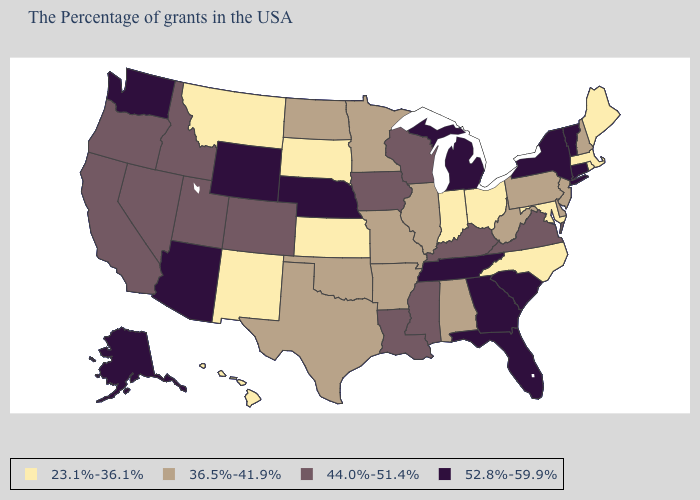Name the states that have a value in the range 23.1%-36.1%?
Write a very short answer. Maine, Massachusetts, Rhode Island, Maryland, North Carolina, Ohio, Indiana, Kansas, South Dakota, New Mexico, Montana, Hawaii. What is the highest value in the South ?
Be succinct. 52.8%-59.9%. What is the value of Oklahoma?
Concise answer only. 36.5%-41.9%. What is the value of Oklahoma?
Write a very short answer. 36.5%-41.9%. Name the states that have a value in the range 52.8%-59.9%?
Quick response, please. Vermont, Connecticut, New York, South Carolina, Florida, Georgia, Michigan, Tennessee, Nebraska, Wyoming, Arizona, Washington, Alaska. Name the states that have a value in the range 52.8%-59.9%?
Give a very brief answer. Vermont, Connecticut, New York, South Carolina, Florida, Georgia, Michigan, Tennessee, Nebraska, Wyoming, Arizona, Washington, Alaska. Among the states that border New Mexico , does Colorado have the highest value?
Write a very short answer. No. Is the legend a continuous bar?
Keep it brief. No. Does the map have missing data?
Give a very brief answer. No. Name the states that have a value in the range 36.5%-41.9%?
Give a very brief answer. New Hampshire, New Jersey, Delaware, Pennsylvania, West Virginia, Alabama, Illinois, Missouri, Arkansas, Minnesota, Oklahoma, Texas, North Dakota. What is the value of Idaho?
Be succinct. 44.0%-51.4%. Does Maryland have the highest value in the USA?
Write a very short answer. No. Name the states that have a value in the range 36.5%-41.9%?
Be succinct. New Hampshire, New Jersey, Delaware, Pennsylvania, West Virginia, Alabama, Illinois, Missouri, Arkansas, Minnesota, Oklahoma, Texas, North Dakota. What is the lowest value in the Northeast?
Answer briefly. 23.1%-36.1%. Which states have the lowest value in the USA?
Concise answer only. Maine, Massachusetts, Rhode Island, Maryland, North Carolina, Ohio, Indiana, Kansas, South Dakota, New Mexico, Montana, Hawaii. 